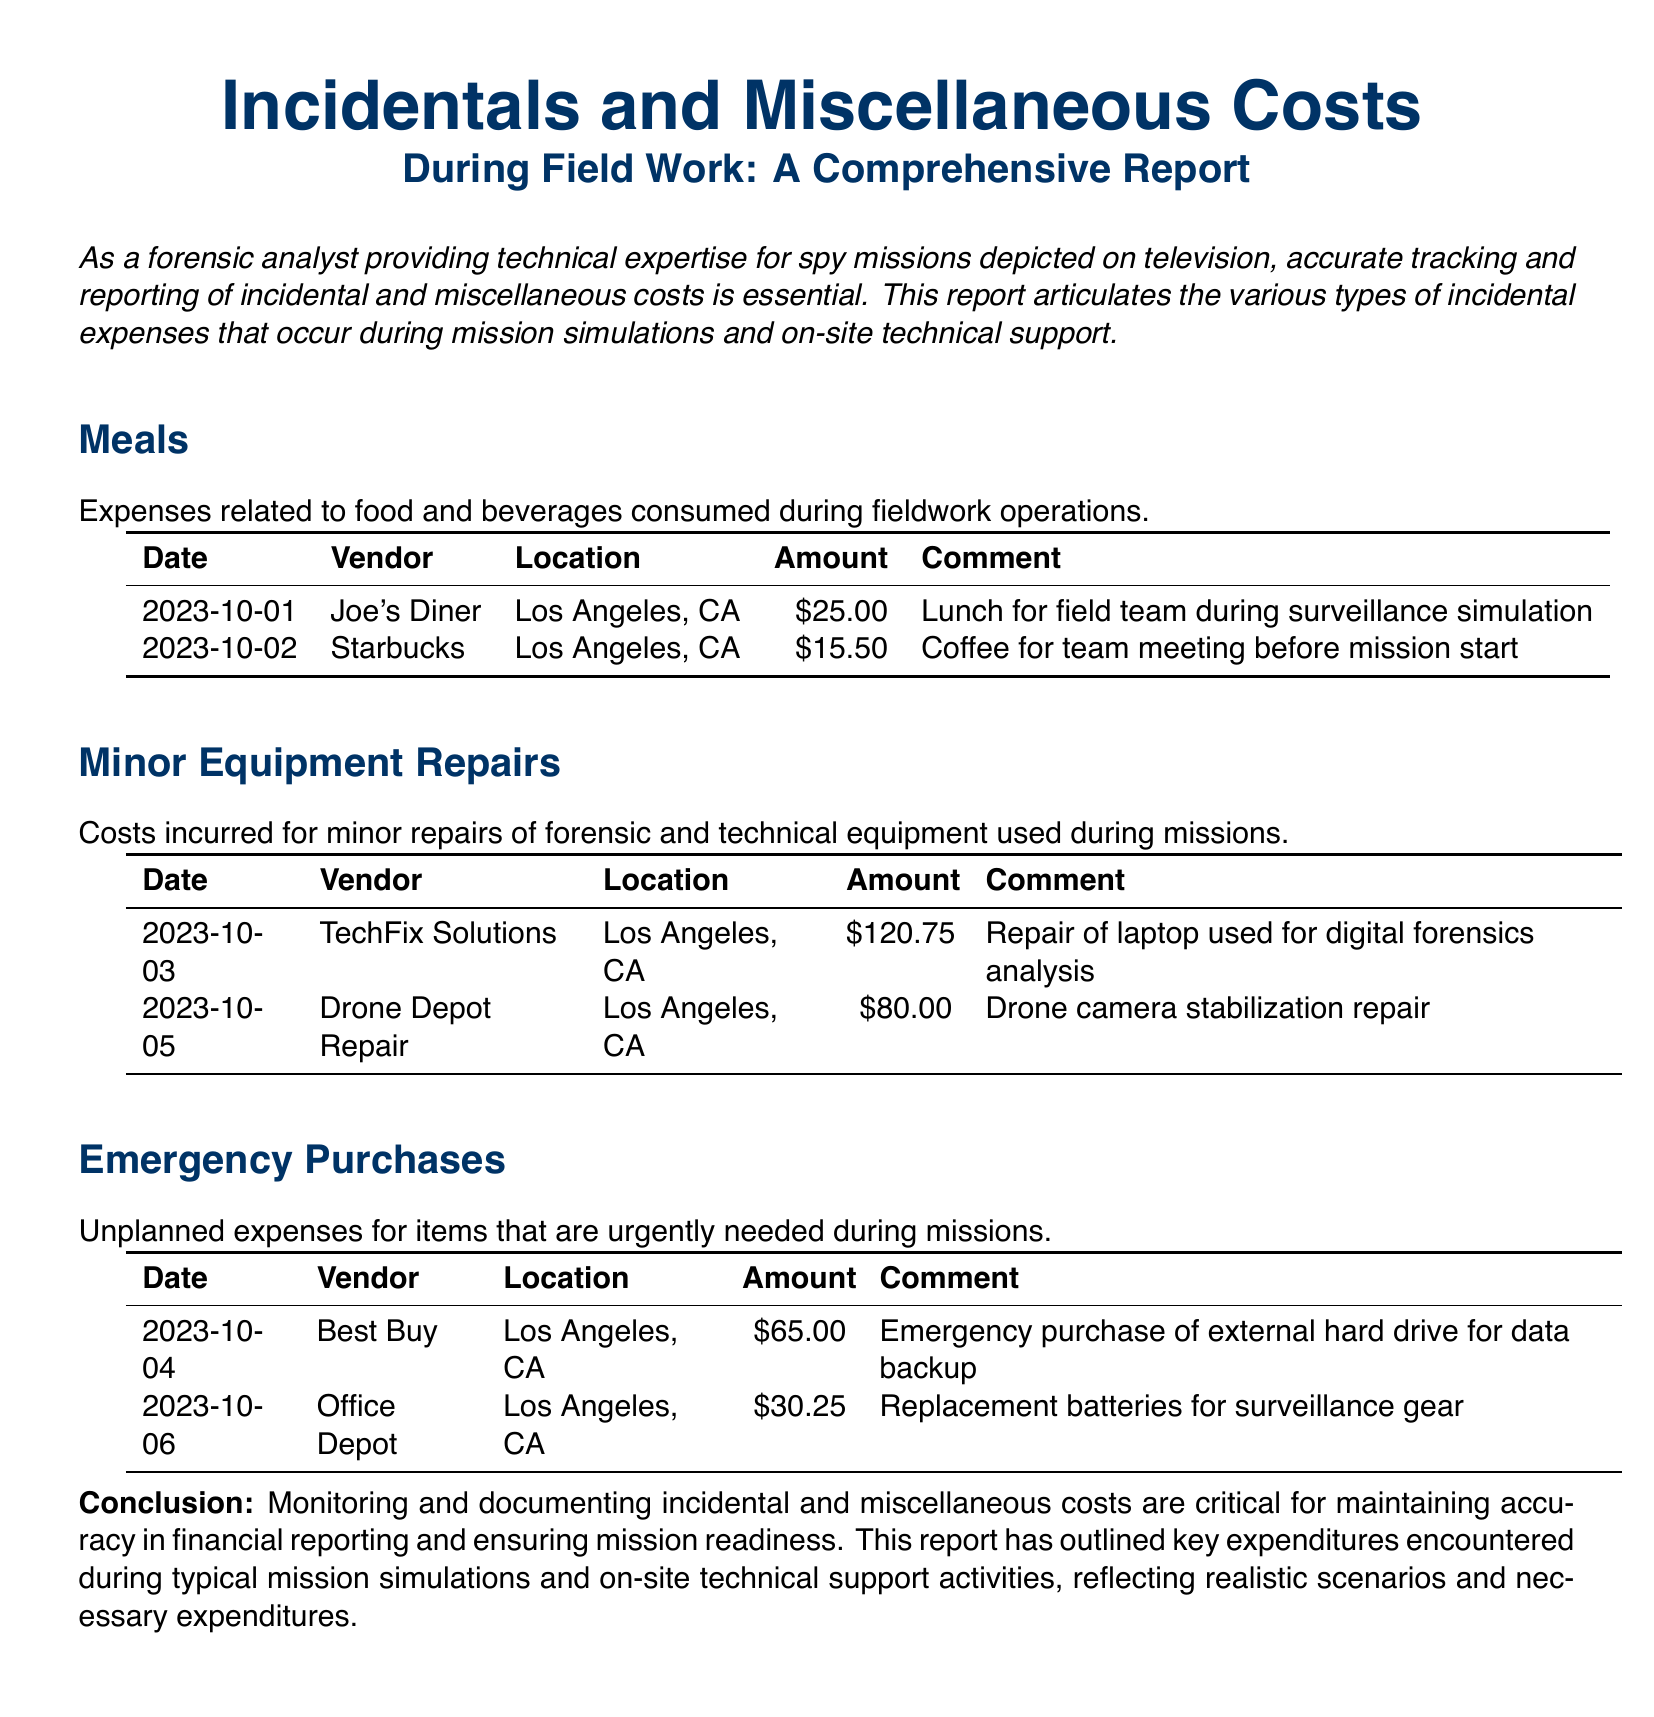What is the total amount spent on meals? The total amount is the sum of all meal costs listed in the report, which is $25.00 + $15.50 = $40.50.
Answer: $40.50 How many minor equipment repairs were reported? The number of entries under the Minor Equipment Repairs section provides this information, amounting to two repairs.
Answer: 2 What was the cost of the repair for the laptop? The specific entry under Minor Equipment Repairs shows the laptop repair cost as $120.75.
Answer: $120.75 Which vendor provided the external hard drive? The Emergency Purchases section including the item purchased identifies Best Buy as the vendor for the external hard drive.
Answer: Best Buy What type of item was purchased on 2023-10-06? The entry under Emergency Purchases indicates that replacement batteries were the item bought on this date.
Answer: Replacement batteries 